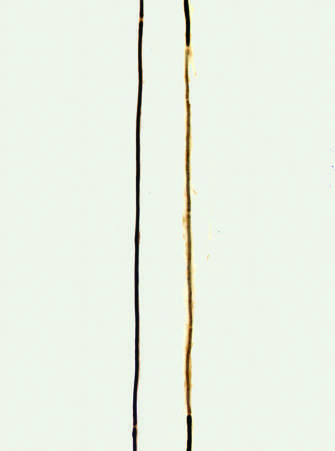what is flanked by nodes of ranvier?
Answer the question using a single word or phrase. A normal axon 